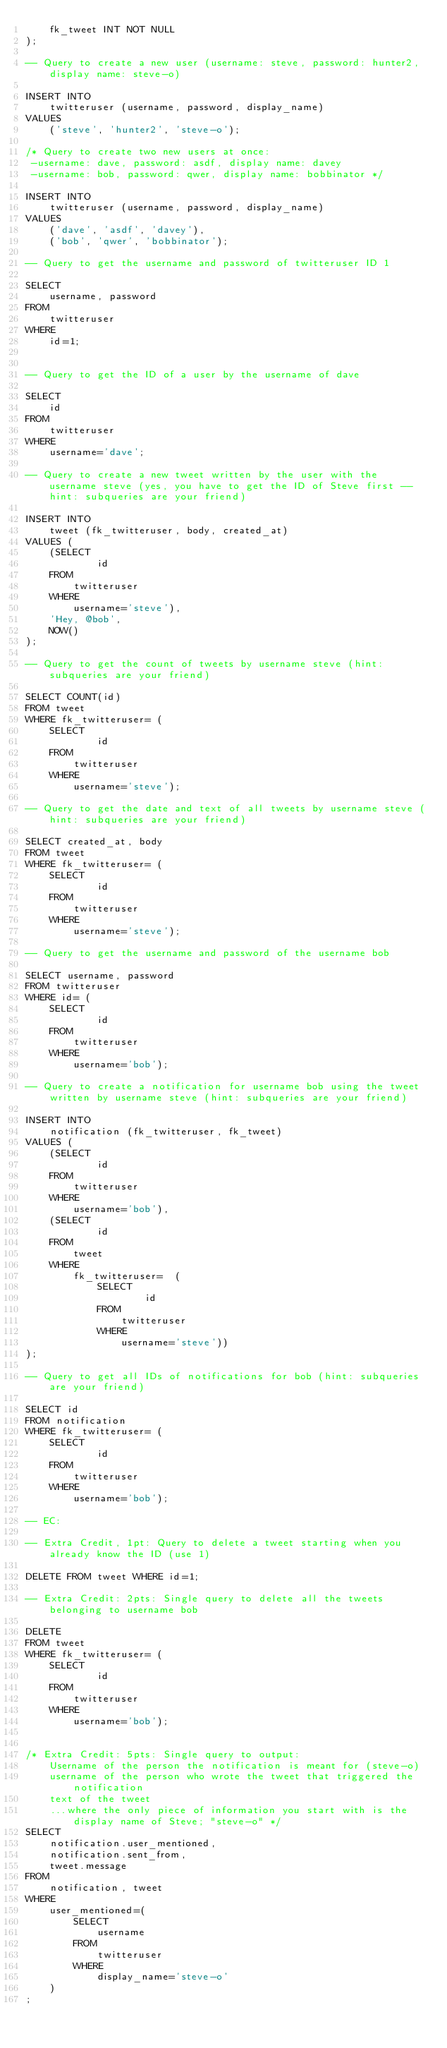Convert code to text. <code><loc_0><loc_0><loc_500><loc_500><_SQL_>    fk_tweet INT NOT NULL
);

-- Query to create a new user (username: steve, password: hunter2, display name: steve-o)

INSERT INTO 
    twitteruser (username, password, display_name)
VALUES 
    ('steve', 'hunter2', 'steve-o');

/* Query to create two new users at once: 
 -username: dave, password: asdf, display name: davey
 -username: bob, password: qwer, display name: bobbinator */

INSERT INTO 
    twitteruser (username, password, display_name)
VALUES
    ('dave', 'asdf', 'davey'),
    ('bob', 'qwer', 'bobbinator');
 
-- Query to get the username and password of twitteruser ID 1

SELECT 
    username, password 
FROM 
    twitteruser
WHERE 
    id=1;


-- Query to get the ID of a user by the username of dave

SELECT 
    id 
FROM 
    twitteruser
WHERE 
    username='dave';

-- Query to create a new tweet written by the user with the username steve (yes, you have to get the ID of Steve first -- hint: subqueries are your friend)

INSERT INTO
    tweet (fk_twitteruser, body, created_at)
VALUES (
    (SELECT
            id
    FROM
        twitteruser
    WHERE
        username='steve'),
    'Hey, @bob',
    NOW()
);

-- Query to get the count of tweets by username steve (hint: subqueries are your friend)

SELECT COUNT(id)
FROM tweet
WHERE fk_twitteruser= (
    SELECT
            id
    FROM
        twitteruser
    WHERE
        username='steve');

-- Query to get the date and text of all tweets by username steve (hint: subqueries are your friend)

SELECT created_at, body
FROM tweet
WHERE fk_twitteruser= (
    SELECT
            id
    FROM
        twitteruser
    WHERE
        username='steve');

-- Query to get the username and password of the username bob

SELECT username, password
FROM twitteruser
WHERE id= (
    SELECT
            id
    FROM
        twitteruser
    WHERE
        username='bob');

-- Query to create a notification for username bob using the tweet written by username steve (hint: subqueries are your friend)

INSERT INTO 
    notification (fk_twitteruser, fk_tweet)
VALUES (
    (SELECT
            id
    FROM
        twitteruser
    WHERE
        username='bob'),
    (SELECT
            id
    FROM
        tweet
    WHERE
        fk_twitteruser=  (
            SELECT
                    id
            FROM
                twitteruser
            WHERE
                username='steve'))
);

-- Query to get all IDs of notifications for bob (hint: subqueries are your friend)

SELECT id
FROM notification
WHERE fk_twitteruser= (
    SELECT
            id
    FROM
        twitteruser
    WHERE
        username='bob');

-- EC: 

-- Extra Credit, 1pt: Query to delete a tweet starting when you already know the ID (use 1)

DELETE FROM tweet WHERE id=1;

-- Extra Credit: 2pts: Single query to delete all the tweets belonging to username bob

DELETE
FROM tweet 
WHERE fk_twitteruser= (
    SELECT
            id
    FROM
        twitteruser
    WHERE
        username='bob');


/* Extra Credit: 5pts: Single query to output:
    Username of the person the notification is meant for (steve-o)
    username of the person who wrote the tweet that triggered the notification
    text of the tweet
    ...where the only piece of information you start with is the display name of Steve; "steve-o" */
SELECT
    notification.user_mentioned,
    notification.sent_from,
    tweet.message
FROM
    notification, tweet
WHERE
    user_mentioned=(
        SELECT
            username
        FROM
            twitteruser
        WHERE
            display_name='steve-o'
    )
;

    
    
</code> 